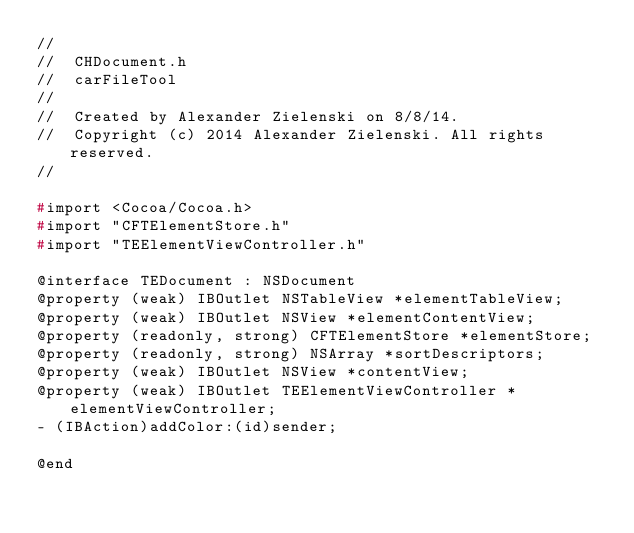Convert code to text. <code><loc_0><loc_0><loc_500><loc_500><_C_>//
//  CHDocument.h
//  carFileTool
//
//  Created by Alexander Zielenski on 8/8/14.
//  Copyright (c) 2014 Alexander Zielenski. All rights reserved.
//

#import <Cocoa/Cocoa.h>
#import "CFTElementStore.h"
#import "TEElementViewController.h"

@interface TEDocument : NSDocument
@property (weak) IBOutlet NSTableView *elementTableView;
@property (weak) IBOutlet NSView *elementContentView;
@property (readonly, strong) CFTElementStore *elementStore;
@property (readonly, strong) NSArray *sortDescriptors;
@property (weak) IBOutlet NSView *contentView;
@property (weak) IBOutlet TEElementViewController *elementViewController;
- (IBAction)addColor:(id)sender;

@end
</code> 